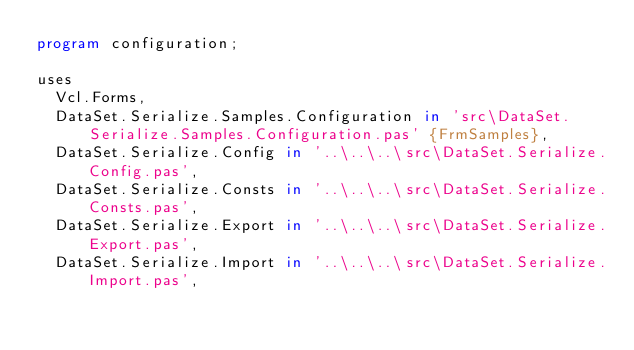Convert code to text. <code><loc_0><loc_0><loc_500><loc_500><_Pascal_>program configuration;

uses
  Vcl.Forms,
  DataSet.Serialize.Samples.Configuration in 'src\DataSet.Serialize.Samples.Configuration.pas' {FrmSamples},
  DataSet.Serialize.Config in '..\..\..\src\DataSet.Serialize.Config.pas',
  DataSet.Serialize.Consts in '..\..\..\src\DataSet.Serialize.Consts.pas',
  DataSet.Serialize.Export in '..\..\..\src\DataSet.Serialize.Export.pas',
  DataSet.Serialize.Import in '..\..\..\src\DataSet.Serialize.Import.pas',</code> 